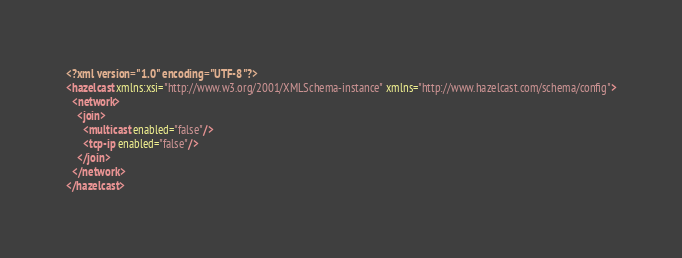Convert code to text. <code><loc_0><loc_0><loc_500><loc_500><_XML_><?xml version="1.0" encoding="UTF-8"?>
<hazelcast xmlns:xsi="http://www.w3.org/2001/XMLSchema-instance" xmlns="http://www.hazelcast.com/schema/config">
  <network>
    <join>
      <multicast enabled="false"/>
      <tcp-ip enabled="false"/>
    </join>
  </network>
</hazelcast>
</code> 